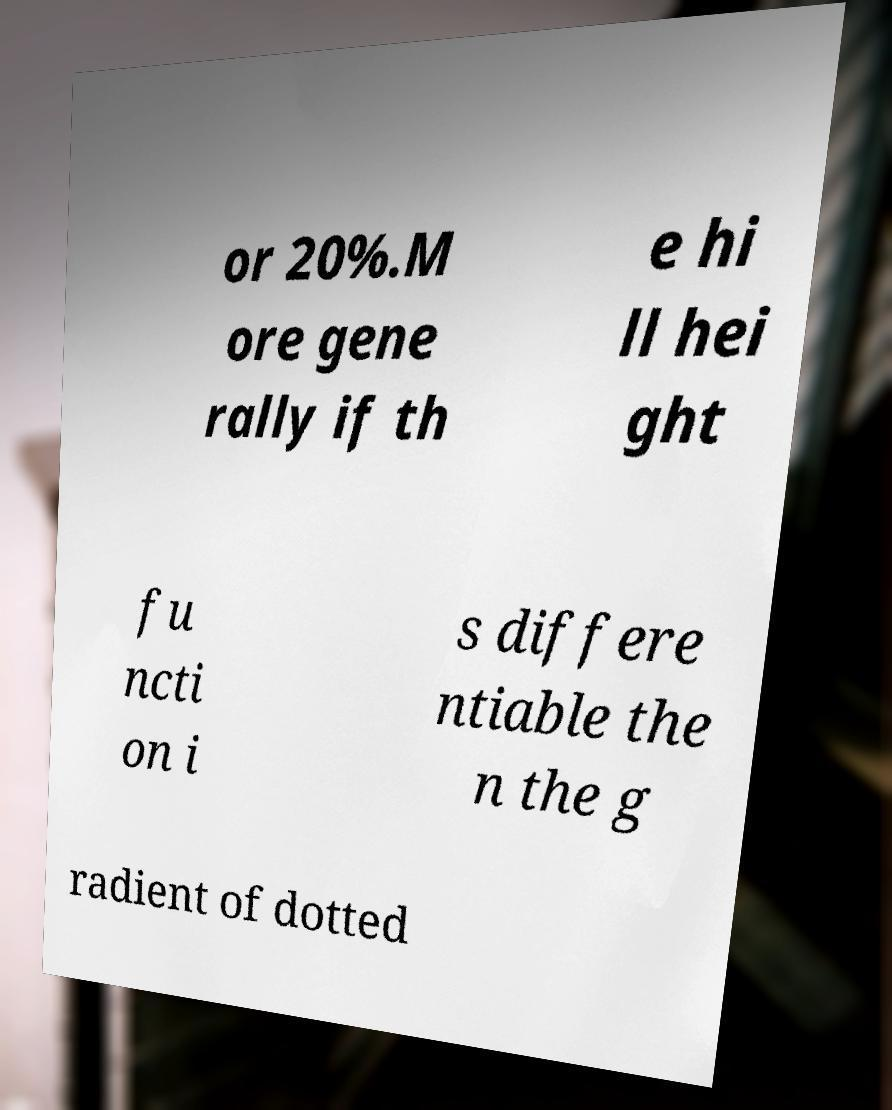I need the written content from this picture converted into text. Can you do that? or 20%.M ore gene rally if th e hi ll hei ght fu ncti on i s differe ntiable the n the g radient of dotted 